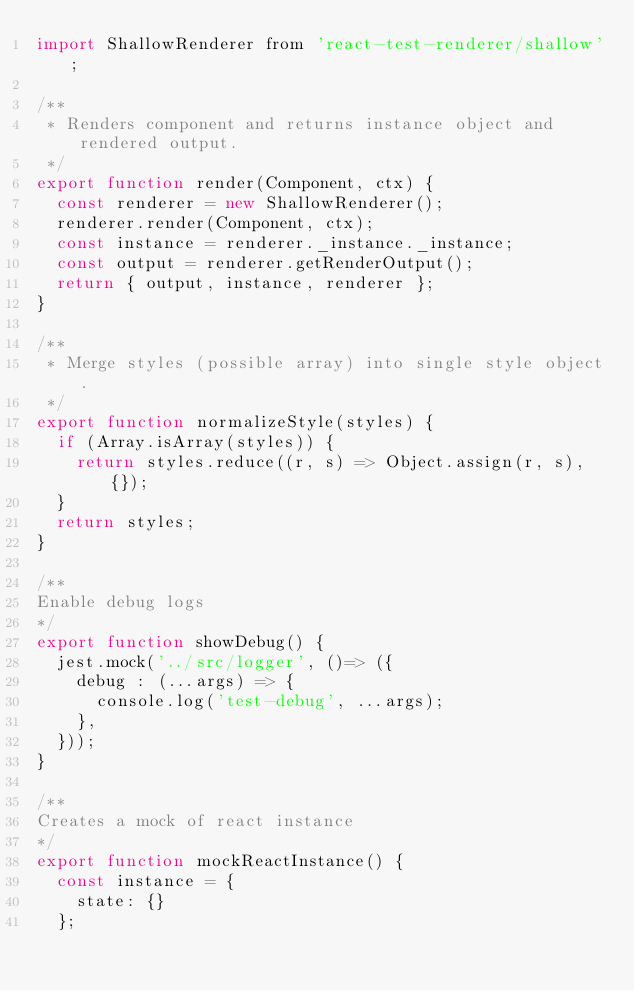<code> <loc_0><loc_0><loc_500><loc_500><_JavaScript_>import ShallowRenderer from 'react-test-renderer/shallow';

/**
 * Renders component and returns instance object and rendered output.
 */
export function render(Component, ctx) {
  const renderer = new ShallowRenderer();
  renderer.render(Component, ctx);
  const instance = renderer._instance._instance;
  const output = renderer.getRenderOutput();
  return { output, instance, renderer };
}

/**
 * Merge styles (possible array) into single style object.
 */
export function normalizeStyle(styles) {
  if (Array.isArray(styles)) {
    return styles.reduce((r, s) => Object.assign(r, s), {});
  }
  return styles;
}

/**
Enable debug logs
*/
export function showDebug() {
  jest.mock('../src/logger', ()=> ({
    debug : (...args) => {
      console.log('test-debug', ...args);
    },
  }));
}

/**
Creates a mock of react instance
*/
export function mockReactInstance() {
  const instance = {
    state: {}
  };</code> 